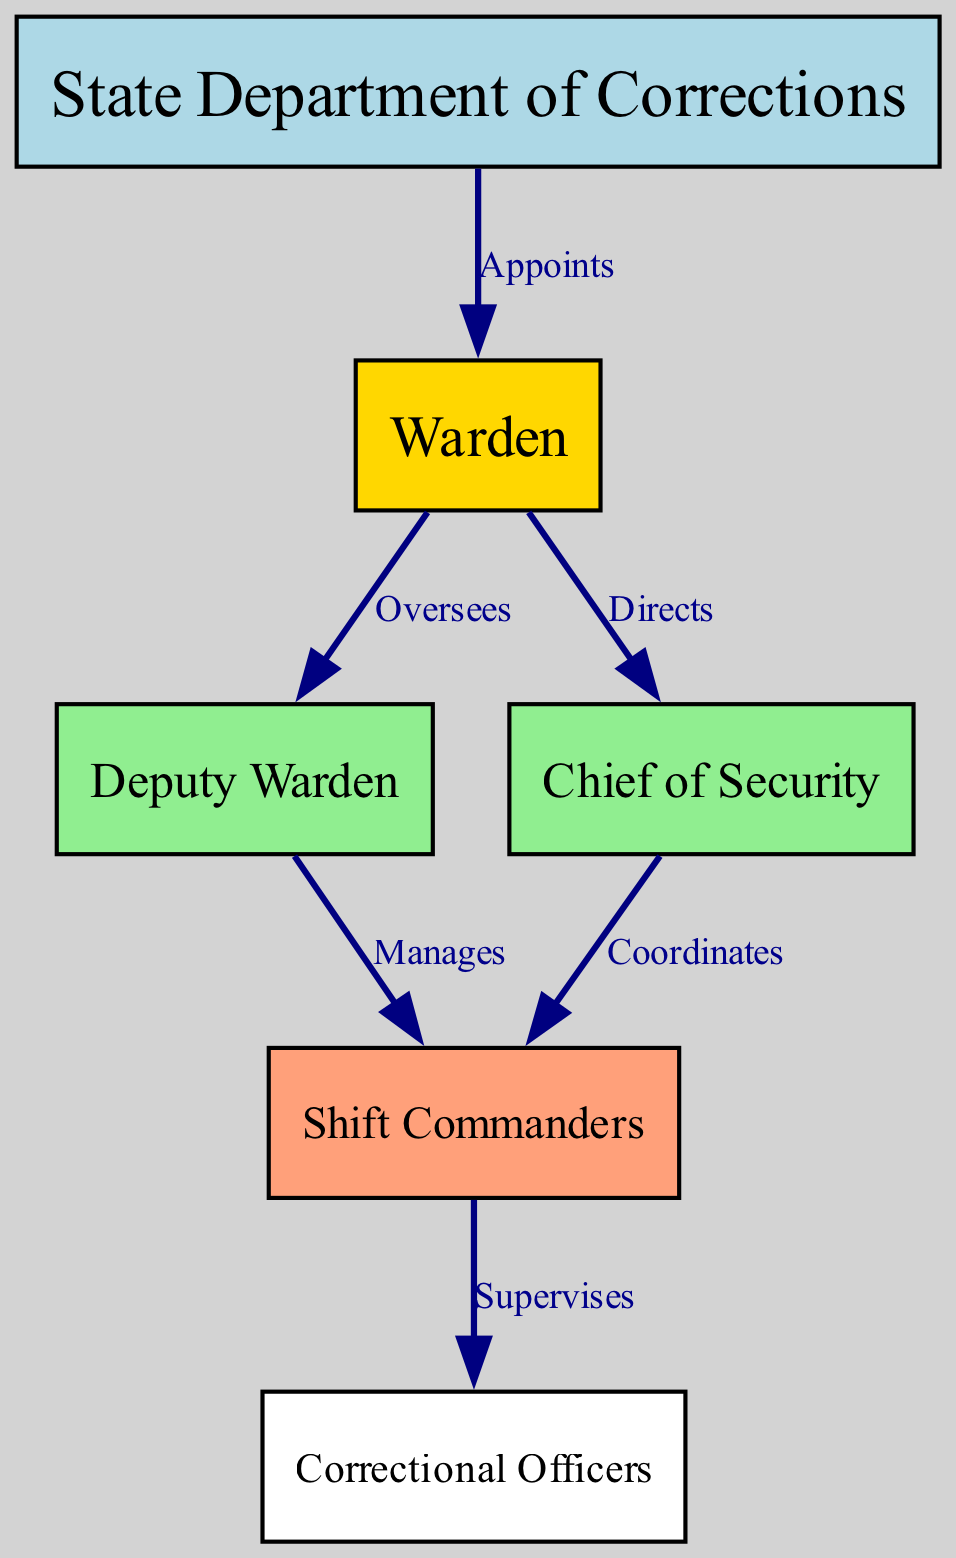What is the top node in the hierarchy? The top node in the diagram represents the highest authority in the correctional facility, which is the State Department of Corrections.
Answer: State Department of Corrections How many nodes are in the diagram? By counting the individual nodes listed, there are a total of six nodes: State Department of Corrections, Warden, Deputy Warden, Chief of Security, Shift Commanders, and Correctional Officers.
Answer: 6 Who appoints the Warden? According to the diagram, the Warden is appointed by the State Department of Corrections, indicating the authority that establishes the Warden’s position within the facility.
Answer: State Department of Corrections What is the relationship between the Warden and the Deputy Warden? The diagram shows that the Warden oversees the Deputy Warden, indicating a direct supervisory relationship where the Warden is responsible for guiding the Deputy Warden’s actions.
Answer: Oversees How many edges are connected to the Chief of Security? By reviewing the edges, the Chief of Security has two connections: one to the Warden and another to the Shift Commanders, showing how this role coordinates with higher and lower levels of command.
Answer: 2 What role directly supervises the Correctional Officers? The diagram clearly indicates that the Shift Commanders supervise the Correctional Officers, highlighting the chain of command within the facility.
Answer: Shift Commanders If the Deputy Warden manages the Shift Commanders, who manages the Deputy Warden? The Deputy Warden is managed by the Warden, creating a structured hierarchy where each level reports to the one above it, emphasizing the organized command within the facility.
Answer: Warden What role has the responsibility to coordinate with the Shift Commanders? The Chief of Security coordinates with the Shift Commanders as indicated by the diagram, representing the collaboration between security management and operational oversight.
Answer: Chief of Security What color represents the Warden in the diagram? In the diagram, the Warden is represented in gold, distinguishing this role from others in the hierarchy and emphasizing its leadership position within the correctional facility.
Answer: Gold 